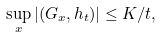Convert formula to latex. <formula><loc_0><loc_0><loc_500><loc_500>\sup _ { x } | ( G _ { x } , h _ { t } ) | \leq K / t ,</formula> 